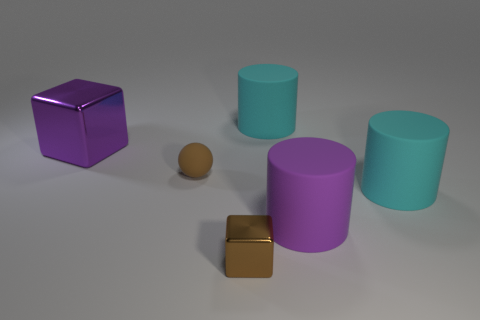Can you describe the colors of the objects present in the image? Certainly! There are two prominent colors in the objects visible in the image. The two cubes have a shiny purple color and a gold-like hue, respectively. The cylindrical objects come in two shades: a soft aquamarine and a deeper mauve. 